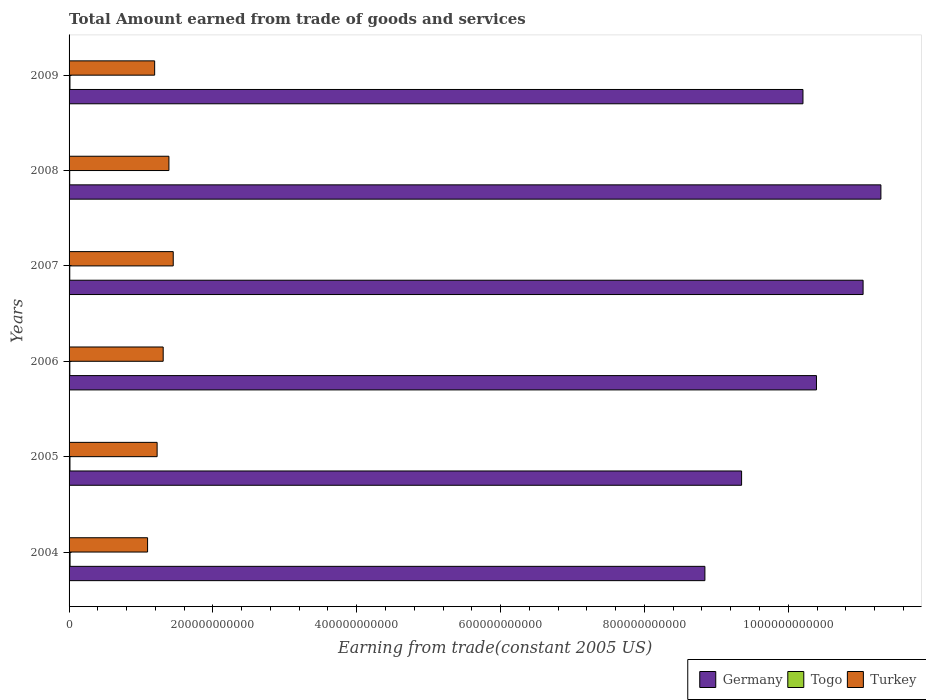Are the number of bars per tick equal to the number of legend labels?
Give a very brief answer. Yes. Are the number of bars on each tick of the Y-axis equal?
Ensure brevity in your answer.  Yes. How many bars are there on the 3rd tick from the top?
Your answer should be very brief. 3. How many bars are there on the 4th tick from the bottom?
Keep it short and to the point. 3. In how many cases, is the number of bars for a given year not equal to the number of legend labels?
Ensure brevity in your answer.  0. What is the total amount earned by trading goods and services in Turkey in 2005?
Your answer should be compact. 1.22e+11. Across all years, what is the maximum total amount earned by trading goods and services in Togo?
Offer a terse response. 1.38e+09. Across all years, what is the minimum total amount earned by trading goods and services in Togo?
Offer a terse response. 8.85e+08. What is the total total amount earned by trading goods and services in Germany in the graph?
Provide a succinct answer. 6.11e+12. What is the difference between the total amount earned by trading goods and services in Togo in 2007 and that in 2009?
Your answer should be very brief. -2.72e+08. What is the difference between the total amount earned by trading goods and services in Turkey in 2004 and the total amount earned by trading goods and services in Togo in 2009?
Give a very brief answer. 1.08e+11. What is the average total amount earned by trading goods and services in Togo per year?
Provide a short and direct response. 1.13e+09. In the year 2008, what is the difference between the total amount earned by trading goods and services in Germany and total amount earned by trading goods and services in Togo?
Keep it short and to the point. 1.13e+12. What is the ratio of the total amount earned by trading goods and services in Germany in 2005 to that in 2009?
Provide a succinct answer. 0.92. Is the total amount earned by trading goods and services in Togo in 2005 less than that in 2008?
Provide a short and direct response. No. What is the difference between the highest and the second highest total amount earned by trading goods and services in Germany?
Make the answer very short. 2.48e+1. What is the difference between the highest and the lowest total amount earned by trading goods and services in Turkey?
Your response must be concise. 3.57e+1. In how many years, is the total amount earned by trading goods and services in Germany greater than the average total amount earned by trading goods and services in Germany taken over all years?
Your response must be concise. 4. Is the sum of the total amount earned by trading goods and services in Germany in 2007 and 2009 greater than the maximum total amount earned by trading goods and services in Turkey across all years?
Offer a terse response. Yes. How many years are there in the graph?
Your answer should be very brief. 6. What is the difference between two consecutive major ticks on the X-axis?
Keep it short and to the point. 2.00e+11. Are the values on the major ticks of X-axis written in scientific E-notation?
Offer a terse response. No. Does the graph contain any zero values?
Your answer should be very brief. No. What is the title of the graph?
Provide a short and direct response. Total Amount earned from trade of goods and services. What is the label or title of the X-axis?
Your response must be concise. Earning from trade(constant 2005 US). What is the label or title of the Y-axis?
Offer a terse response. Years. What is the Earning from trade(constant 2005 US) of Germany in 2004?
Offer a very short reply. 8.84e+11. What is the Earning from trade(constant 2005 US) of Togo in 2004?
Keep it short and to the point. 1.38e+09. What is the Earning from trade(constant 2005 US) of Turkey in 2004?
Offer a terse response. 1.09e+11. What is the Earning from trade(constant 2005 US) in Germany in 2005?
Offer a very short reply. 9.35e+11. What is the Earning from trade(constant 2005 US) of Togo in 2005?
Your answer should be very brief. 1.24e+09. What is the Earning from trade(constant 2005 US) of Turkey in 2005?
Give a very brief answer. 1.22e+11. What is the Earning from trade(constant 2005 US) in Germany in 2006?
Provide a succinct answer. 1.04e+12. What is the Earning from trade(constant 2005 US) in Togo in 2006?
Ensure brevity in your answer.  1.05e+09. What is the Earning from trade(constant 2005 US) of Turkey in 2006?
Make the answer very short. 1.31e+11. What is the Earning from trade(constant 2005 US) in Germany in 2007?
Make the answer very short. 1.10e+12. What is the Earning from trade(constant 2005 US) of Togo in 2007?
Your answer should be compact. 9.69e+08. What is the Earning from trade(constant 2005 US) in Turkey in 2007?
Provide a short and direct response. 1.45e+11. What is the Earning from trade(constant 2005 US) in Germany in 2008?
Provide a short and direct response. 1.13e+12. What is the Earning from trade(constant 2005 US) in Togo in 2008?
Make the answer very short. 8.85e+08. What is the Earning from trade(constant 2005 US) in Turkey in 2008?
Offer a terse response. 1.39e+11. What is the Earning from trade(constant 2005 US) of Germany in 2009?
Your answer should be very brief. 1.02e+12. What is the Earning from trade(constant 2005 US) of Togo in 2009?
Ensure brevity in your answer.  1.24e+09. What is the Earning from trade(constant 2005 US) in Turkey in 2009?
Your answer should be very brief. 1.19e+11. Across all years, what is the maximum Earning from trade(constant 2005 US) in Germany?
Keep it short and to the point. 1.13e+12. Across all years, what is the maximum Earning from trade(constant 2005 US) of Togo?
Your answer should be compact. 1.38e+09. Across all years, what is the maximum Earning from trade(constant 2005 US) of Turkey?
Offer a very short reply. 1.45e+11. Across all years, what is the minimum Earning from trade(constant 2005 US) in Germany?
Offer a very short reply. 8.84e+11. Across all years, what is the minimum Earning from trade(constant 2005 US) in Togo?
Provide a short and direct response. 8.85e+08. Across all years, what is the minimum Earning from trade(constant 2005 US) of Turkey?
Offer a very short reply. 1.09e+11. What is the total Earning from trade(constant 2005 US) of Germany in the graph?
Provide a succinct answer. 6.11e+12. What is the total Earning from trade(constant 2005 US) in Togo in the graph?
Ensure brevity in your answer.  6.77e+09. What is the total Earning from trade(constant 2005 US) in Turkey in the graph?
Offer a terse response. 7.65e+11. What is the difference between the Earning from trade(constant 2005 US) of Germany in 2004 and that in 2005?
Your answer should be compact. -5.10e+1. What is the difference between the Earning from trade(constant 2005 US) of Togo in 2004 and that in 2005?
Provide a short and direct response. 1.39e+08. What is the difference between the Earning from trade(constant 2005 US) of Turkey in 2004 and that in 2005?
Keep it short and to the point. -1.33e+1. What is the difference between the Earning from trade(constant 2005 US) of Germany in 2004 and that in 2006?
Provide a short and direct response. -1.55e+11. What is the difference between the Earning from trade(constant 2005 US) of Togo in 2004 and that in 2006?
Your answer should be very brief. 3.29e+08. What is the difference between the Earning from trade(constant 2005 US) in Turkey in 2004 and that in 2006?
Provide a succinct answer. -2.17e+1. What is the difference between the Earning from trade(constant 2005 US) of Germany in 2004 and that in 2007?
Your answer should be compact. -2.20e+11. What is the difference between the Earning from trade(constant 2005 US) of Togo in 2004 and that in 2007?
Offer a very short reply. 4.11e+08. What is the difference between the Earning from trade(constant 2005 US) in Turkey in 2004 and that in 2007?
Ensure brevity in your answer.  -3.57e+1. What is the difference between the Earning from trade(constant 2005 US) of Germany in 2004 and that in 2008?
Offer a terse response. -2.45e+11. What is the difference between the Earning from trade(constant 2005 US) in Togo in 2004 and that in 2008?
Your answer should be compact. 4.95e+08. What is the difference between the Earning from trade(constant 2005 US) of Turkey in 2004 and that in 2008?
Offer a very short reply. -2.97e+1. What is the difference between the Earning from trade(constant 2005 US) of Germany in 2004 and that in 2009?
Give a very brief answer. -1.36e+11. What is the difference between the Earning from trade(constant 2005 US) of Togo in 2004 and that in 2009?
Your answer should be very brief. 1.39e+08. What is the difference between the Earning from trade(constant 2005 US) in Turkey in 2004 and that in 2009?
Your answer should be very brief. -9.84e+09. What is the difference between the Earning from trade(constant 2005 US) in Germany in 2005 and that in 2006?
Your answer should be very brief. -1.04e+11. What is the difference between the Earning from trade(constant 2005 US) of Togo in 2005 and that in 2006?
Your response must be concise. 1.90e+08. What is the difference between the Earning from trade(constant 2005 US) in Turkey in 2005 and that in 2006?
Offer a very short reply. -8.43e+09. What is the difference between the Earning from trade(constant 2005 US) in Germany in 2005 and that in 2007?
Offer a very short reply. -1.69e+11. What is the difference between the Earning from trade(constant 2005 US) in Togo in 2005 and that in 2007?
Ensure brevity in your answer.  2.72e+08. What is the difference between the Earning from trade(constant 2005 US) in Turkey in 2005 and that in 2007?
Ensure brevity in your answer.  -2.24e+1. What is the difference between the Earning from trade(constant 2005 US) of Germany in 2005 and that in 2008?
Give a very brief answer. -1.94e+11. What is the difference between the Earning from trade(constant 2005 US) in Togo in 2005 and that in 2008?
Give a very brief answer. 3.56e+08. What is the difference between the Earning from trade(constant 2005 US) of Turkey in 2005 and that in 2008?
Offer a terse response. -1.64e+1. What is the difference between the Earning from trade(constant 2005 US) of Germany in 2005 and that in 2009?
Your answer should be compact. -8.53e+1. What is the difference between the Earning from trade(constant 2005 US) in Togo in 2005 and that in 2009?
Your answer should be very brief. -5.73e+05. What is the difference between the Earning from trade(constant 2005 US) of Turkey in 2005 and that in 2009?
Keep it short and to the point. 3.44e+09. What is the difference between the Earning from trade(constant 2005 US) of Germany in 2006 and that in 2007?
Ensure brevity in your answer.  -6.48e+1. What is the difference between the Earning from trade(constant 2005 US) in Togo in 2006 and that in 2007?
Provide a succinct answer. 8.15e+07. What is the difference between the Earning from trade(constant 2005 US) of Turkey in 2006 and that in 2007?
Make the answer very short. -1.40e+1. What is the difference between the Earning from trade(constant 2005 US) in Germany in 2006 and that in 2008?
Provide a short and direct response. -8.96e+1. What is the difference between the Earning from trade(constant 2005 US) of Togo in 2006 and that in 2008?
Your answer should be compact. 1.66e+08. What is the difference between the Earning from trade(constant 2005 US) in Turkey in 2006 and that in 2008?
Your response must be concise. -7.97e+09. What is the difference between the Earning from trade(constant 2005 US) of Germany in 2006 and that in 2009?
Your answer should be very brief. 1.88e+1. What is the difference between the Earning from trade(constant 2005 US) of Togo in 2006 and that in 2009?
Give a very brief answer. -1.91e+08. What is the difference between the Earning from trade(constant 2005 US) of Turkey in 2006 and that in 2009?
Your response must be concise. 1.19e+1. What is the difference between the Earning from trade(constant 2005 US) in Germany in 2007 and that in 2008?
Your response must be concise. -2.48e+1. What is the difference between the Earning from trade(constant 2005 US) of Togo in 2007 and that in 2008?
Offer a terse response. 8.41e+07. What is the difference between the Earning from trade(constant 2005 US) in Turkey in 2007 and that in 2008?
Make the answer very short. 5.98e+09. What is the difference between the Earning from trade(constant 2005 US) in Germany in 2007 and that in 2009?
Provide a short and direct response. 8.36e+1. What is the difference between the Earning from trade(constant 2005 US) in Togo in 2007 and that in 2009?
Give a very brief answer. -2.72e+08. What is the difference between the Earning from trade(constant 2005 US) in Turkey in 2007 and that in 2009?
Keep it short and to the point. 2.58e+1. What is the difference between the Earning from trade(constant 2005 US) in Germany in 2008 and that in 2009?
Keep it short and to the point. 1.08e+11. What is the difference between the Earning from trade(constant 2005 US) in Togo in 2008 and that in 2009?
Give a very brief answer. -3.56e+08. What is the difference between the Earning from trade(constant 2005 US) in Turkey in 2008 and that in 2009?
Keep it short and to the point. 1.99e+1. What is the difference between the Earning from trade(constant 2005 US) in Germany in 2004 and the Earning from trade(constant 2005 US) in Togo in 2005?
Your answer should be very brief. 8.83e+11. What is the difference between the Earning from trade(constant 2005 US) of Germany in 2004 and the Earning from trade(constant 2005 US) of Turkey in 2005?
Ensure brevity in your answer.  7.62e+11. What is the difference between the Earning from trade(constant 2005 US) of Togo in 2004 and the Earning from trade(constant 2005 US) of Turkey in 2005?
Ensure brevity in your answer.  -1.21e+11. What is the difference between the Earning from trade(constant 2005 US) of Germany in 2004 and the Earning from trade(constant 2005 US) of Togo in 2006?
Keep it short and to the point. 8.83e+11. What is the difference between the Earning from trade(constant 2005 US) of Germany in 2004 and the Earning from trade(constant 2005 US) of Turkey in 2006?
Your answer should be compact. 7.53e+11. What is the difference between the Earning from trade(constant 2005 US) in Togo in 2004 and the Earning from trade(constant 2005 US) in Turkey in 2006?
Provide a succinct answer. -1.29e+11. What is the difference between the Earning from trade(constant 2005 US) in Germany in 2004 and the Earning from trade(constant 2005 US) in Togo in 2007?
Offer a terse response. 8.83e+11. What is the difference between the Earning from trade(constant 2005 US) of Germany in 2004 and the Earning from trade(constant 2005 US) of Turkey in 2007?
Give a very brief answer. 7.39e+11. What is the difference between the Earning from trade(constant 2005 US) in Togo in 2004 and the Earning from trade(constant 2005 US) in Turkey in 2007?
Give a very brief answer. -1.43e+11. What is the difference between the Earning from trade(constant 2005 US) in Germany in 2004 and the Earning from trade(constant 2005 US) in Togo in 2008?
Give a very brief answer. 8.83e+11. What is the difference between the Earning from trade(constant 2005 US) in Germany in 2004 and the Earning from trade(constant 2005 US) in Turkey in 2008?
Offer a very short reply. 7.45e+11. What is the difference between the Earning from trade(constant 2005 US) of Togo in 2004 and the Earning from trade(constant 2005 US) of Turkey in 2008?
Provide a succinct answer. -1.37e+11. What is the difference between the Earning from trade(constant 2005 US) in Germany in 2004 and the Earning from trade(constant 2005 US) in Togo in 2009?
Your answer should be very brief. 8.83e+11. What is the difference between the Earning from trade(constant 2005 US) of Germany in 2004 and the Earning from trade(constant 2005 US) of Turkey in 2009?
Your response must be concise. 7.65e+11. What is the difference between the Earning from trade(constant 2005 US) in Togo in 2004 and the Earning from trade(constant 2005 US) in Turkey in 2009?
Make the answer very short. -1.18e+11. What is the difference between the Earning from trade(constant 2005 US) of Germany in 2005 and the Earning from trade(constant 2005 US) of Togo in 2006?
Your answer should be compact. 9.34e+11. What is the difference between the Earning from trade(constant 2005 US) of Germany in 2005 and the Earning from trade(constant 2005 US) of Turkey in 2006?
Keep it short and to the point. 8.04e+11. What is the difference between the Earning from trade(constant 2005 US) in Togo in 2005 and the Earning from trade(constant 2005 US) in Turkey in 2006?
Offer a very short reply. -1.30e+11. What is the difference between the Earning from trade(constant 2005 US) of Germany in 2005 and the Earning from trade(constant 2005 US) of Togo in 2007?
Offer a terse response. 9.34e+11. What is the difference between the Earning from trade(constant 2005 US) in Germany in 2005 and the Earning from trade(constant 2005 US) in Turkey in 2007?
Your answer should be compact. 7.90e+11. What is the difference between the Earning from trade(constant 2005 US) in Togo in 2005 and the Earning from trade(constant 2005 US) in Turkey in 2007?
Provide a short and direct response. -1.44e+11. What is the difference between the Earning from trade(constant 2005 US) of Germany in 2005 and the Earning from trade(constant 2005 US) of Togo in 2008?
Provide a short and direct response. 9.34e+11. What is the difference between the Earning from trade(constant 2005 US) of Germany in 2005 and the Earning from trade(constant 2005 US) of Turkey in 2008?
Keep it short and to the point. 7.96e+11. What is the difference between the Earning from trade(constant 2005 US) of Togo in 2005 and the Earning from trade(constant 2005 US) of Turkey in 2008?
Ensure brevity in your answer.  -1.38e+11. What is the difference between the Earning from trade(constant 2005 US) in Germany in 2005 and the Earning from trade(constant 2005 US) in Togo in 2009?
Give a very brief answer. 9.34e+11. What is the difference between the Earning from trade(constant 2005 US) of Germany in 2005 and the Earning from trade(constant 2005 US) of Turkey in 2009?
Your answer should be compact. 8.16e+11. What is the difference between the Earning from trade(constant 2005 US) in Togo in 2005 and the Earning from trade(constant 2005 US) in Turkey in 2009?
Give a very brief answer. -1.18e+11. What is the difference between the Earning from trade(constant 2005 US) in Germany in 2006 and the Earning from trade(constant 2005 US) in Togo in 2007?
Your answer should be compact. 1.04e+12. What is the difference between the Earning from trade(constant 2005 US) in Germany in 2006 and the Earning from trade(constant 2005 US) in Turkey in 2007?
Your response must be concise. 8.94e+11. What is the difference between the Earning from trade(constant 2005 US) in Togo in 2006 and the Earning from trade(constant 2005 US) in Turkey in 2007?
Keep it short and to the point. -1.44e+11. What is the difference between the Earning from trade(constant 2005 US) in Germany in 2006 and the Earning from trade(constant 2005 US) in Togo in 2008?
Provide a succinct answer. 1.04e+12. What is the difference between the Earning from trade(constant 2005 US) of Germany in 2006 and the Earning from trade(constant 2005 US) of Turkey in 2008?
Make the answer very short. 9.00e+11. What is the difference between the Earning from trade(constant 2005 US) of Togo in 2006 and the Earning from trade(constant 2005 US) of Turkey in 2008?
Offer a terse response. -1.38e+11. What is the difference between the Earning from trade(constant 2005 US) in Germany in 2006 and the Earning from trade(constant 2005 US) in Togo in 2009?
Keep it short and to the point. 1.04e+12. What is the difference between the Earning from trade(constant 2005 US) of Germany in 2006 and the Earning from trade(constant 2005 US) of Turkey in 2009?
Ensure brevity in your answer.  9.20e+11. What is the difference between the Earning from trade(constant 2005 US) in Togo in 2006 and the Earning from trade(constant 2005 US) in Turkey in 2009?
Offer a terse response. -1.18e+11. What is the difference between the Earning from trade(constant 2005 US) in Germany in 2007 and the Earning from trade(constant 2005 US) in Togo in 2008?
Your response must be concise. 1.10e+12. What is the difference between the Earning from trade(constant 2005 US) of Germany in 2007 and the Earning from trade(constant 2005 US) of Turkey in 2008?
Provide a succinct answer. 9.65e+11. What is the difference between the Earning from trade(constant 2005 US) in Togo in 2007 and the Earning from trade(constant 2005 US) in Turkey in 2008?
Provide a succinct answer. -1.38e+11. What is the difference between the Earning from trade(constant 2005 US) of Germany in 2007 and the Earning from trade(constant 2005 US) of Togo in 2009?
Ensure brevity in your answer.  1.10e+12. What is the difference between the Earning from trade(constant 2005 US) in Germany in 2007 and the Earning from trade(constant 2005 US) in Turkey in 2009?
Your answer should be compact. 9.85e+11. What is the difference between the Earning from trade(constant 2005 US) in Togo in 2007 and the Earning from trade(constant 2005 US) in Turkey in 2009?
Make the answer very short. -1.18e+11. What is the difference between the Earning from trade(constant 2005 US) of Germany in 2008 and the Earning from trade(constant 2005 US) of Togo in 2009?
Make the answer very short. 1.13e+12. What is the difference between the Earning from trade(constant 2005 US) in Germany in 2008 and the Earning from trade(constant 2005 US) in Turkey in 2009?
Your answer should be very brief. 1.01e+12. What is the difference between the Earning from trade(constant 2005 US) of Togo in 2008 and the Earning from trade(constant 2005 US) of Turkey in 2009?
Provide a succinct answer. -1.18e+11. What is the average Earning from trade(constant 2005 US) in Germany per year?
Provide a short and direct response. 1.02e+12. What is the average Earning from trade(constant 2005 US) in Togo per year?
Offer a very short reply. 1.13e+09. What is the average Earning from trade(constant 2005 US) in Turkey per year?
Ensure brevity in your answer.  1.28e+11. In the year 2004, what is the difference between the Earning from trade(constant 2005 US) in Germany and Earning from trade(constant 2005 US) in Togo?
Offer a very short reply. 8.83e+11. In the year 2004, what is the difference between the Earning from trade(constant 2005 US) of Germany and Earning from trade(constant 2005 US) of Turkey?
Provide a succinct answer. 7.75e+11. In the year 2004, what is the difference between the Earning from trade(constant 2005 US) in Togo and Earning from trade(constant 2005 US) in Turkey?
Your answer should be compact. -1.08e+11. In the year 2005, what is the difference between the Earning from trade(constant 2005 US) of Germany and Earning from trade(constant 2005 US) of Togo?
Offer a terse response. 9.34e+11. In the year 2005, what is the difference between the Earning from trade(constant 2005 US) in Germany and Earning from trade(constant 2005 US) in Turkey?
Your response must be concise. 8.13e+11. In the year 2005, what is the difference between the Earning from trade(constant 2005 US) in Togo and Earning from trade(constant 2005 US) in Turkey?
Provide a succinct answer. -1.21e+11. In the year 2006, what is the difference between the Earning from trade(constant 2005 US) in Germany and Earning from trade(constant 2005 US) in Togo?
Your answer should be compact. 1.04e+12. In the year 2006, what is the difference between the Earning from trade(constant 2005 US) of Germany and Earning from trade(constant 2005 US) of Turkey?
Make the answer very short. 9.08e+11. In the year 2006, what is the difference between the Earning from trade(constant 2005 US) of Togo and Earning from trade(constant 2005 US) of Turkey?
Keep it short and to the point. -1.30e+11. In the year 2007, what is the difference between the Earning from trade(constant 2005 US) of Germany and Earning from trade(constant 2005 US) of Togo?
Offer a terse response. 1.10e+12. In the year 2007, what is the difference between the Earning from trade(constant 2005 US) in Germany and Earning from trade(constant 2005 US) in Turkey?
Your answer should be very brief. 9.59e+11. In the year 2007, what is the difference between the Earning from trade(constant 2005 US) in Togo and Earning from trade(constant 2005 US) in Turkey?
Ensure brevity in your answer.  -1.44e+11. In the year 2008, what is the difference between the Earning from trade(constant 2005 US) of Germany and Earning from trade(constant 2005 US) of Togo?
Give a very brief answer. 1.13e+12. In the year 2008, what is the difference between the Earning from trade(constant 2005 US) in Germany and Earning from trade(constant 2005 US) in Turkey?
Give a very brief answer. 9.90e+11. In the year 2008, what is the difference between the Earning from trade(constant 2005 US) of Togo and Earning from trade(constant 2005 US) of Turkey?
Make the answer very short. -1.38e+11. In the year 2009, what is the difference between the Earning from trade(constant 2005 US) of Germany and Earning from trade(constant 2005 US) of Togo?
Offer a very short reply. 1.02e+12. In the year 2009, what is the difference between the Earning from trade(constant 2005 US) in Germany and Earning from trade(constant 2005 US) in Turkey?
Offer a terse response. 9.01e+11. In the year 2009, what is the difference between the Earning from trade(constant 2005 US) in Togo and Earning from trade(constant 2005 US) in Turkey?
Offer a terse response. -1.18e+11. What is the ratio of the Earning from trade(constant 2005 US) in Germany in 2004 to that in 2005?
Give a very brief answer. 0.95. What is the ratio of the Earning from trade(constant 2005 US) of Togo in 2004 to that in 2005?
Provide a short and direct response. 1.11. What is the ratio of the Earning from trade(constant 2005 US) in Turkey in 2004 to that in 2005?
Give a very brief answer. 0.89. What is the ratio of the Earning from trade(constant 2005 US) in Germany in 2004 to that in 2006?
Offer a terse response. 0.85. What is the ratio of the Earning from trade(constant 2005 US) in Togo in 2004 to that in 2006?
Your answer should be very brief. 1.31. What is the ratio of the Earning from trade(constant 2005 US) in Turkey in 2004 to that in 2006?
Make the answer very short. 0.83. What is the ratio of the Earning from trade(constant 2005 US) in Germany in 2004 to that in 2007?
Make the answer very short. 0.8. What is the ratio of the Earning from trade(constant 2005 US) in Togo in 2004 to that in 2007?
Give a very brief answer. 1.42. What is the ratio of the Earning from trade(constant 2005 US) in Turkey in 2004 to that in 2007?
Offer a very short reply. 0.75. What is the ratio of the Earning from trade(constant 2005 US) in Germany in 2004 to that in 2008?
Make the answer very short. 0.78. What is the ratio of the Earning from trade(constant 2005 US) of Togo in 2004 to that in 2008?
Give a very brief answer. 1.56. What is the ratio of the Earning from trade(constant 2005 US) of Turkey in 2004 to that in 2008?
Provide a succinct answer. 0.79. What is the ratio of the Earning from trade(constant 2005 US) of Germany in 2004 to that in 2009?
Your answer should be very brief. 0.87. What is the ratio of the Earning from trade(constant 2005 US) of Togo in 2004 to that in 2009?
Provide a succinct answer. 1.11. What is the ratio of the Earning from trade(constant 2005 US) in Turkey in 2004 to that in 2009?
Your answer should be compact. 0.92. What is the ratio of the Earning from trade(constant 2005 US) in Germany in 2005 to that in 2006?
Your answer should be compact. 0.9. What is the ratio of the Earning from trade(constant 2005 US) in Togo in 2005 to that in 2006?
Make the answer very short. 1.18. What is the ratio of the Earning from trade(constant 2005 US) in Turkey in 2005 to that in 2006?
Offer a very short reply. 0.94. What is the ratio of the Earning from trade(constant 2005 US) in Germany in 2005 to that in 2007?
Your answer should be very brief. 0.85. What is the ratio of the Earning from trade(constant 2005 US) of Togo in 2005 to that in 2007?
Make the answer very short. 1.28. What is the ratio of the Earning from trade(constant 2005 US) of Turkey in 2005 to that in 2007?
Your answer should be compact. 0.85. What is the ratio of the Earning from trade(constant 2005 US) of Germany in 2005 to that in 2008?
Your response must be concise. 0.83. What is the ratio of the Earning from trade(constant 2005 US) in Togo in 2005 to that in 2008?
Give a very brief answer. 1.4. What is the ratio of the Earning from trade(constant 2005 US) of Turkey in 2005 to that in 2008?
Keep it short and to the point. 0.88. What is the ratio of the Earning from trade(constant 2005 US) of Germany in 2005 to that in 2009?
Make the answer very short. 0.92. What is the ratio of the Earning from trade(constant 2005 US) of Turkey in 2005 to that in 2009?
Offer a terse response. 1.03. What is the ratio of the Earning from trade(constant 2005 US) of Germany in 2006 to that in 2007?
Keep it short and to the point. 0.94. What is the ratio of the Earning from trade(constant 2005 US) of Togo in 2006 to that in 2007?
Provide a short and direct response. 1.08. What is the ratio of the Earning from trade(constant 2005 US) in Turkey in 2006 to that in 2007?
Provide a short and direct response. 0.9. What is the ratio of the Earning from trade(constant 2005 US) of Germany in 2006 to that in 2008?
Offer a very short reply. 0.92. What is the ratio of the Earning from trade(constant 2005 US) of Togo in 2006 to that in 2008?
Provide a succinct answer. 1.19. What is the ratio of the Earning from trade(constant 2005 US) of Turkey in 2006 to that in 2008?
Provide a succinct answer. 0.94. What is the ratio of the Earning from trade(constant 2005 US) in Germany in 2006 to that in 2009?
Make the answer very short. 1.02. What is the ratio of the Earning from trade(constant 2005 US) of Togo in 2006 to that in 2009?
Offer a very short reply. 0.85. What is the ratio of the Earning from trade(constant 2005 US) of Turkey in 2006 to that in 2009?
Offer a terse response. 1.1. What is the ratio of the Earning from trade(constant 2005 US) of Germany in 2007 to that in 2008?
Keep it short and to the point. 0.98. What is the ratio of the Earning from trade(constant 2005 US) of Togo in 2007 to that in 2008?
Ensure brevity in your answer.  1.09. What is the ratio of the Earning from trade(constant 2005 US) of Turkey in 2007 to that in 2008?
Keep it short and to the point. 1.04. What is the ratio of the Earning from trade(constant 2005 US) in Germany in 2007 to that in 2009?
Offer a terse response. 1.08. What is the ratio of the Earning from trade(constant 2005 US) of Togo in 2007 to that in 2009?
Offer a terse response. 0.78. What is the ratio of the Earning from trade(constant 2005 US) in Turkey in 2007 to that in 2009?
Your response must be concise. 1.22. What is the ratio of the Earning from trade(constant 2005 US) in Germany in 2008 to that in 2009?
Ensure brevity in your answer.  1.11. What is the ratio of the Earning from trade(constant 2005 US) in Togo in 2008 to that in 2009?
Your answer should be compact. 0.71. What is the ratio of the Earning from trade(constant 2005 US) in Turkey in 2008 to that in 2009?
Your response must be concise. 1.17. What is the difference between the highest and the second highest Earning from trade(constant 2005 US) of Germany?
Offer a terse response. 2.48e+1. What is the difference between the highest and the second highest Earning from trade(constant 2005 US) of Togo?
Your answer should be very brief. 1.39e+08. What is the difference between the highest and the second highest Earning from trade(constant 2005 US) of Turkey?
Provide a succinct answer. 5.98e+09. What is the difference between the highest and the lowest Earning from trade(constant 2005 US) in Germany?
Keep it short and to the point. 2.45e+11. What is the difference between the highest and the lowest Earning from trade(constant 2005 US) of Togo?
Ensure brevity in your answer.  4.95e+08. What is the difference between the highest and the lowest Earning from trade(constant 2005 US) of Turkey?
Make the answer very short. 3.57e+1. 